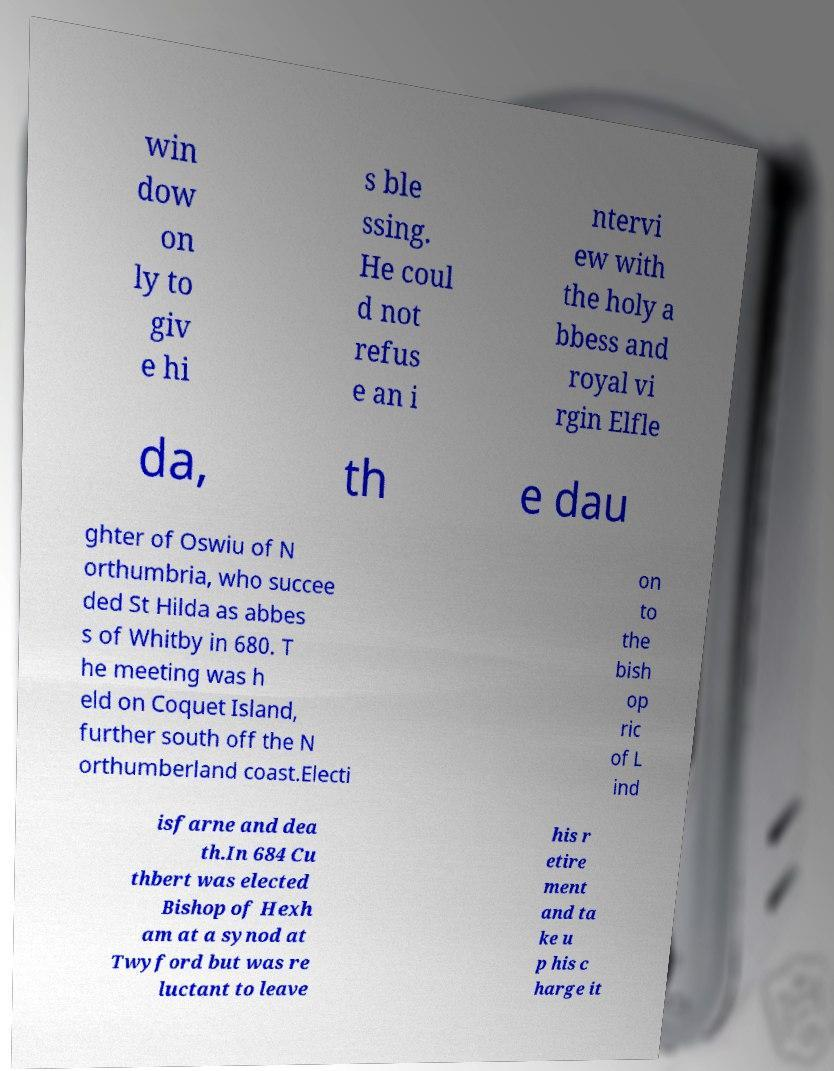I need the written content from this picture converted into text. Can you do that? win dow on ly to giv e hi s ble ssing. He coul d not refus e an i ntervi ew with the holy a bbess and royal vi rgin Elfle da, th e dau ghter of Oswiu of N orthumbria, who succee ded St Hilda as abbes s of Whitby in 680. T he meeting was h eld on Coquet Island, further south off the N orthumberland coast.Electi on to the bish op ric of L ind isfarne and dea th.In 684 Cu thbert was elected Bishop of Hexh am at a synod at Twyford but was re luctant to leave his r etire ment and ta ke u p his c harge it 